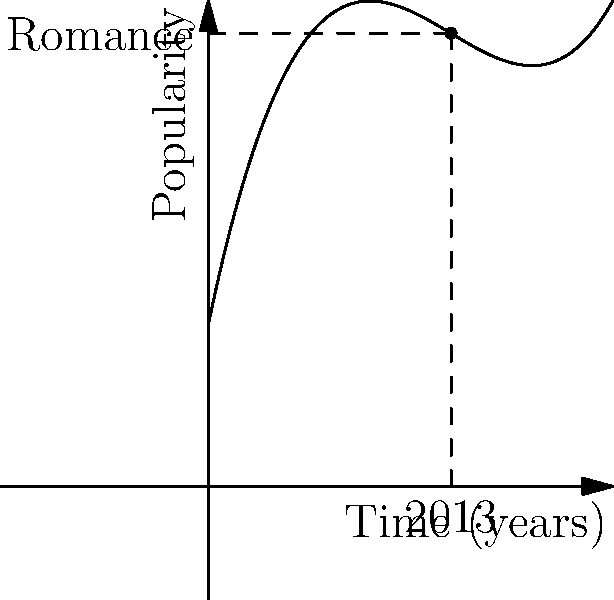The graph represents the popularity of the romance genre over the past decade. At the point corresponding to the year 2013, what is the instantaneous rate of change in the genre's popularity? Use the concept of the derivative to find the slope of the tangent line at this point. To find the instantaneous rate of change at a specific point, we need to calculate the derivative of the function at that point. Let's approach this step-by-step:

1) The function representing the popularity seems to be of the form:
   $f(x) = 0.2x^3 - 1.8x^2 + 4.8x + 2$

2) To find the derivative, we use the power rule:
   $f'(x) = 0.6x^2 - 3.6x + 4.8$

3) The point of interest is at x = 3 (representing 2013):

4) We substitute x = 3 into the derivative function:
   $f'(3) = 0.6(3)^2 - 3.6(3) + 4.8$
   $     = 0.6(9) - 10.8 + 4.8$
   $     = 5.4 - 10.8 + 4.8$
   $     = -0.6$

5) The negative value indicates that the popularity was decreasing at this point.

6) Interpreting the result: In 2013, the instantaneous rate of change of the romance genre's popularity was -0.6 units per year.
Answer: -0.6 units per year 